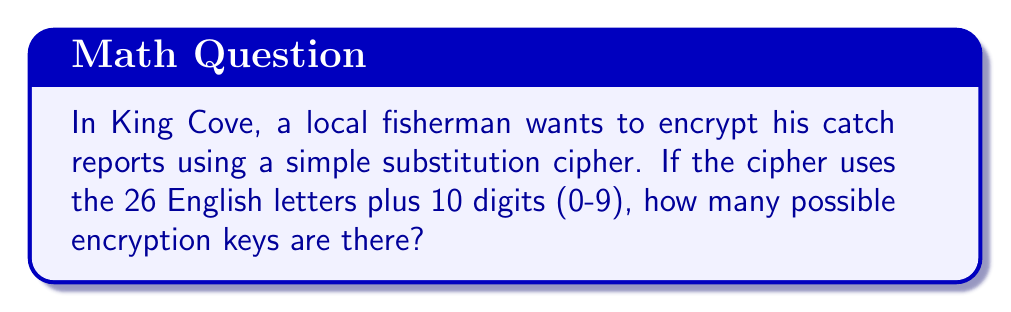Solve this math problem. Let's approach this step-by-step:

1) In a simple substitution cipher, each character in the plaintext is replaced by another character in the ciphertext.

2) We have 36 characters in total (26 letters + 10 digits).

3) For the first character, we have 36 choices.

4) For the second character, we have 35 choices (because one character has already been used).

5) For the third character, we have 34 choices, and so on.

6) This continues until we've assigned all 36 characters.

7) This scenario follows the principle of permutations without repetition.

8) The number of permutations is given by the factorial of the number of elements:

   $$36! = 36 \times 35 \times 34 \times ... \times 3 \times 2 \times 1$$

9) We can calculate this:

   $$36! = 3.7199 \times 10^{41}$$

Therefore, there are approximately $3.7199 \times 10^{41}$ possible encryption keys for this cipher.
Answer: $36!$ or approximately $3.7199 \times 10^{41}$ 